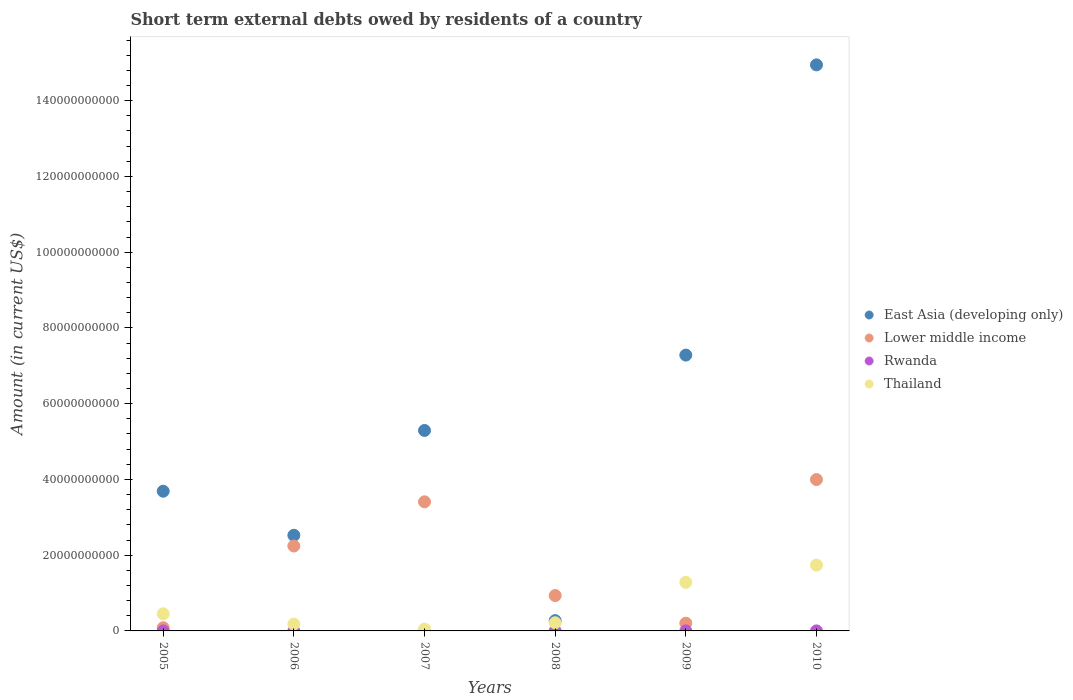Is the number of dotlines equal to the number of legend labels?
Keep it short and to the point. No. What is the amount of short-term external debts owed by residents in Rwanda in 2010?
Keep it short and to the point. 4.00e+06. Across all years, what is the maximum amount of short-term external debts owed by residents in Lower middle income?
Your response must be concise. 4.00e+1. Across all years, what is the minimum amount of short-term external debts owed by residents in East Asia (developing only)?
Offer a terse response. 2.72e+09. In which year was the amount of short-term external debts owed by residents in Lower middle income maximum?
Make the answer very short. 2010. What is the total amount of short-term external debts owed by residents in Lower middle income in the graph?
Provide a short and direct response. 1.09e+11. What is the difference between the amount of short-term external debts owed by residents in Rwanda in 2008 and that in 2010?
Keep it short and to the point. 9.99e+05. What is the difference between the amount of short-term external debts owed by residents in Lower middle income in 2005 and the amount of short-term external debts owed by residents in East Asia (developing only) in 2008?
Your response must be concise. -1.88e+09. What is the average amount of short-term external debts owed by residents in East Asia (developing only) per year?
Your answer should be very brief. 5.67e+1. In the year 2009, what is the difference between the amount of short-term external debts owed by residents in Lower middle income and amount of short-term external debts owed by residents in East Asia (developing only)?
Provide a short and direct response. -7.08e+1. In how many years, is the amount of short-term external debts owed by residents in East Asia (developing only) greater than 124000000000 US$?
Ensure brevity in your answer.  1. What is the ratio of the amount of short-term external debts owed by residents in East Asia (developing only) in 2007 to that in 2009?
Provide a short and direct response. 0.73. Is the amount of short-term external debts owed by residents in Lower middle income in 2005 less than that in 2007?
Your response must be concise. Yes. Is the difference between the amount of short-term external debts owed by residents in Lower middle income in 2006 and 2008 greater than the difference between the amount of short-term external debts owed by residents in East Asia (developing only) in 2006 and 2008?
Provide a short and direct response. No. What is the difference between the highest and the lowest amount of short-term external debts owed by residents in Thailand?
Provide a short and direct response. 1.69e+1. Is the sum of the amount of short-term external debts owed by residents in Lower middle income in 2009 and 2010 greater than the maximum amount of short-term external debts owed by residents in East Asia (developing only) across all years?
Offer a terse response. No. Is it the case that in every year, the sum of the amount of short-term external debts owed by residents in Rwanda and amount of short-term external debts owed by residents in East Asia (developing only)  is greater than the sum of amount of short-term external debts owed by residents in Thailand and amount of short-term external debts owed by residents in Lower middle income?
Your answer should be compact. No. Is the amount of short-term external debts owed by residents in Rwanda strictly less than the amount of short-term external debts owed by residents in East Asia (developing only) over the years?
Your answer should be very brief. Yes. How many years are there in the graph?
Keep it short and to the point. 6. Where does the legend appear in the graph?
Provide a succinct answer. Center right. How many legend labels are there?
Your answer should be very brief. 4. How are the legend labels stacked?
Your answer should be compact. Vertical. What is the title of the graph?
Ensure brevity in your answer.  Short term external debts owed by residents of a country. What is the label or title of the Y-axis?
Offer a very short reply. Amount (in current US$). What is the Amount (in current US$) in East Asia (developing only) in 2005?
Provide a succinct answer. 3.69e+1. What is the Amount (in current US$) of Lower middle income in 2005?
Offer a very short reply. 8.40e+08. What is the Amount (in current US$) of Thailand in 2005?
Make the answer very short. 4.53e+09. What is the Amount (in current US$) in East Asia (developing only) in 2006?
Make the answer very short. 2.53e+1. What is the Amount (in current US$) of Lower middle income in 2006?
Give a very brief answer. 2.24e+1. What is the Amount (in current US$) of Rwanda in 2006?
Give a very brief answer. 3.00e+06. What is the Amount (in current US$) in Thailand in 2006?
Your answer should be compact. 1.80e+09. What is the Amount (in current US$) of East Asia (developing only) in 2007?
Offer a terse response. 5.29e+1. What is the Amount (in current US$) of Lower middle income in 2007?
Your answer should be compact. 3.41e+1. What is the Amount (in current US$) of Rwanda in 2007?
Your answer should be very brief. 0. What is the Amount (in current US$) in Thailand in 2007?
Ensure brevity in your answer.  4.83e+08. What is the Amount (in current US$) in East Asia (developing only) in 2008?
Offer a terse response. 2.72e+09. What is the Amount (in current US$) in Lower middle income in 2008?
Provide a short and direct response. 9.34e+09. What is the Amount (in current US$) in Rwanda in 2008?
Provide a succinct answer. 5.00e+06. What is the Amount (in current US$) in Thailand in 2008?
Your response must be concise. 2.16e+09. What is the Amount (in current US$) of East Asia (developing only) in 2009?
Offer a terse response. 7.28e+1. What is the Amount (in current US$) in Lower middle income in 2009?
Provide a succinct answer. 2.04e+09. What is the Amount (in current US$) in Rwanda in 2009?
Your answer should be very brief. 5.00e+06. What is the Amount (in current US$) of Thailand in 2009?
Offer a terse response. 1.28e+1. What is the Amount (in current US$) in East Asia (developing only) in 2010?
Keep it short and to the point. 1.49e+11. What is the Amount (in current US$) in Lower middle income in 2010?
Offer a terse response. 4.00e+1. What is the Amount (in current US$) in Rwanda in 2010?
Your answer should be very brief. 4.00e+06. What is the Amount (in current US$) in Thailand in 2010?
Your answer should be compact. 1.74e+1. Across all years, what is the maximum Amount (in current US$) in East Asia (developing only)?
Your answer should be compact. 1.49e+11. Across all years, what is the maximum Amount (in current US$) of Lower middle income?
Offer a terse response. 4.00e+1. Across all years, what is the maximum Amount (in current US$) of Thailand?
Give a very brief answer. 1.74e+1. Across all years, what is the minimum Amount (in current US$) in East Asia (developing only)?
Your answer should be compact. 2.72e+09. Across all years, what is the minimum Amount (in current US$) of Lower middle income?
Make the answer very short. 8.40e+08. Across all years, what is the minimum Amount (in current US$) in Rwanda?
Your answer should be very brief. 0. Across all years, what is the minimum Amount (in current US$) of Thailand?
Make the answer very short. 4.83e+08. What is the total Amount (in current US$) of East Asia (developing only) in the graph?
Offer a terse response. 3.40e+11. What is the total Amount (in current US$) of Lower middle income in the graph?
Provide a succinct answer. 1.09e+11. What is the total Amount (in current US$) of Rwanda in the graph?
Offer a terse response. 1.70e+07. What is the total Amount (in current US$) of Thailand in the graph?
Give a very brief answer. 3.92e+1. What is the difference between the Amount (in current US$) in East Asia (developing only) in 2005 and that in 2006?
Your response must be concise. 1.16e+1. What is the difference between the Amount (in current US$) of Lower middle income in 2005 and that in 2006?
Offer a terse response. -2.16e+1. What is the difference between the Amount (in current US$) in Thailand in 2005 and that in 2006?
Offer a very short reply. 2.73e+09. What is the difference between the Amount (in current US$) of East Asia (developing only) in 2005 and that in 2007?
Your answer should be compact. -1.60e+1. What is the difference between the Amount (in current US$) in Lower middle income in 2005 and that in 2007?
Offer a very short reply. -3.32e+1. What is the difference between the Amount (in current US$) in Thailand in 2005 and that in 2007?
Your answer should be very brief. 4.04e+09. What is the difference between the Amount (in current US$) in East Asia (developing only) in 2005 and that in 2008?
Give a very brief answer. 3.42e+1. What is the difference between the Amount (in current US$) in Lower middle income in 2005 and that in 2008?
Offer a very short reply. -8.50e+09. What is the difference between the Amount (in current US$) of Thailand in 2005 and that in 2008?
Make the answer very short. 2.37e+09. What is the difference between the Amount (in current US$) of East Asia (developing only) in 2005 and that in 2009?
Offer a terse response. -3.59e+1. What is the difference between the Amount (in current US$) of Lower middle income in 2005 and that in 2009?
Provide a short and direct response. -1.20e+09. What is the difference between the Amount (in current US$) in Thailand in 2005 and that in 2009?
Keep it short and to the point. -8.30e+09. What is the difference between the Amount (in current US$) of East Asia (developing only) in 2005 and that in 2010?
Give a very brief answer. -1.13e+11. What is the difference between the Amount (in current US$) in Lower middle income in 2005 and that in 2010?
Keep it short and to the point. -3.91e+1. What is the difference between the Amount (in current US$) in Thailand in 2005 and that in 2010?
Make the answer very short. -1.29e+1. What is the difference between the Amount (in current US$) in East Asia (developing only) in 2006 and that in 2007?
Offer a very short reply. -2.77e+1. What is the difference between the Amount (in current US$) of Lower middle income in 2006 and that in 2007?
Give a very brief answer. -1.17e+1. What is the difference between the Amount (in current US$) in Thailand in 2006 and that in 2007?
Keep it short and to the point. 1.32e+09. What is the difference between the Amount (in current US$) in East Asia (developing only) in 2006 and that in 2008?
Your answer should be compact. 2.25e+1. What is the difference between the Amount (in current US$) of Lower middle income in 2006 and that in 2008?
Offer a very short reply. 1.31e+1. What is the difference between the Amount (in current US$) in Rwanda in 2006 and that in 2008?
Offer a very short reply. -2.00e+06. What is the difference between the Amount (in current US$) in Thailand in 2006 and that in 2008?
Give a very brief answer. -3.58e+08. What is the difference between the Amount (in current US$) of East Asia (developing only) in 2006 and that in 2009?
Keep it short and to the point. -4.76e+1. What is the difference between the Amount (in current US$) of Lower middle income in 2006 and that in 2009?
Provide a succinct answer. 2.04e+1. What is the difference between the Amount (in current US$) of Thailand in 2006 and that in 2009?
Ensure brevity in your answer.  -1.10e+1. What is the difference between the Amount (in current US$) of East Asia (developing only) in 2006 and that in 2010?
Your answer should be compact. -1.24e+11. What is the difference between the Amount (in current US$) in Lower middle income in 2006 and that in 2010?
Offer a terse response. -1.75e+1. What is the difference between the Amount (in current US$) in Rwanda in 2006 and that in 2010?
Provide a short and direct response. -1.00e+06. What is the difference between the Amount (in current US$) of Thailand in 2006 and that in 2010?
Provide a short and direct response. -1.56e+1. What is the difference between the Amount (in current US$) in East Asia (developing only) in 2007 and that in 2008?
Your answer should be compact. 5.02e+1. What is the difference between the Amount (in current US$) of Lower middle income in 2007 and that in 2008?
Give a very brief answer. 2.47e+1. What is the difference between the Amount (in current US$) in Thailand in 2007 and that in 2008?
Provide a succinct answer. -1.67e+09. What is the difference between the Amount (in current US$) in East Asia (developing only) in 2007 and that in 2009?
Give a very brief answer. -1.99e+1. What is the difference between the Amount (in current US$) in Lower middle income in 2007 and that in 2009?
Offer a terse response. 3.20e+1. What is the difference between the Amount (in current US$) in Thailand in 2007 and that in 2009?
Your answer should be very brief. -1.23e+1. What is the difference between the Amount (in current US$) of East Asia (developing only) in 2007 and that in 2010?
Offer a very short reply. -9.65e+1. What is the difference between the Amount (in current US$) in Lower middle income in 2007 and that in 2010?
Provide a succinct answer. -5.88e+09. What is the difference between the Amount (in current US$) in Thailand in 2007 and that in 2010?
Your response must be concise. -1.69e+1. What is the difference between the Amount (in current US$) of East Asia (developing only) in 2008 and that in 2009?
Your answer should be compact. -7.01e+1. What is the difference between the Amount (in current US$) in Lower middle income in 2008 and that in 2009?
Give a very brief answer. 7.30e+09. What is the difference between the Amount (in current US$) of Rwanda in 2008 and that in 2009?
Offer a very short reply. -1000. What is the difference between the Amount (in current US$) of Thailand in 2008 and that in 2009?
Offer a terse response. -1.07e+1. What is the difference between the Amount (in current US$) in East Asia (developing only) in 2008 and that in 2010?
Offer a very short reply. -1.47e+11. What is the difference between the Amount (in current US$) in Lower middle income in 2008 and that in 2010?
Keep it short and to the point. -3.06e+1. What is the difference between the Amount (in current US$) of Rwanda in 2008 and that in 2010?
Provide a short and direct response. 9.99e+05. What is the difference between the Amount (in current US$) of Thailand in 2008 and that in 2010?
Provide a short and direct response. -1.52e+1. What is the difference between the Amount (in current US$) in East Asia (developing only) in 2009 and that in 2010?
Your response must be concise. -7.66e+1. What is the difference between the Amount (in current US$) of Lower middle income in 2009 and that in 2010?
Offer a very short reply. -3.79e+1. What is the difference between the Amount (in current US$) of Rwanda in 2009 and that in 2010?
Make the answer very short. 1.00e+06. What is the difference between the Amount (in current US$) of Thailand in 2009 and that in 2010?
Offer a very short reply. -4.55e+09. What is the difference between the Amount (in current US$) in East Asia (developing only) in 2005 and the Amount (in current US$) in Lower middle income in 2006?
Keep it short and to the point. 1.45e+1. What is the difference between the Amount (in current US$) in East Asia (developing only) in 2005 and the Amount (in current US$) in Rwanda in 2006?
Your answer should be very brief. 3.69e+1. What is the difference between the Amount (in current US$) in East Asia (developing only) in 2005 and the Amount (in current US$) in Thailand in 2006?
Your response must be concise. 3.51e+1. What is the difference between the Amount (in current US$) in Lower middle income in 2005 and the Amount (in current US$) in Rwanda in 2006?
Offer a very short reply. 8.37e+08. What is the difference between the Amount (in current US$) of Lower middle income in 2005 and the Amount (in current US$) of Thailand in 2006?
Your response must be concise. -9.58e+08. What is the difference between the Amount (in current US$) of East Asia (developing only) in 2005 and the Amount (in current US$) of Lower middle income in 2007?
Give a very brief answer. 2.80e+09. What is the difference between the Amount (in current US$) of East Asia (developing only) in 2005 and the Amount (in current US$) of Thailand in 2007?
Keep it short and to the point. 3.64e+1. What is the difference between the Amount (in current US$) of Lower middle income in 2005 and the Amount (in current US$) of Thailand in 2007?
Make the answer very short. 3.57e+08. What is the difference between the Amount (in current US$) of East Asia (developing only) in 2005 and the Amount (in current US$) of Lower middle income in 2008?
Offer a very short reply. 2.75e+1. What is the difference between the Amount (in current US$) in East Asia (developing only) in 2005 and the Amount (in current US$) in Rwanda in 2008?
Give a very brief answer. 3.69e+1. What is the difference between the Amount (in current US$) of East Asia (developing only) in 2005 and the Amount (in current US$) of Thailand in 2008?
Your response must be concise. 3.47e+1. What is the difference between the Amount (in current US$) of Lower middle income in 2005 and the Amount (in current US$) of Rwanda in 2008?
Your answer should be compact. 8.35e+08. What is the difference between the Amount (in current US$) in Lower middle income in 2005 and the Amount (in current US$) in Thailand in 2008?
Make the answer very short. -1.32e+09. What is the difference between the Amount (in current US$) of East Asia (developing only) in 2005 and the Amount (in current US$) of Lower middle income in 2009?
Provide a short and direct response. 3.48e+1. What is the difference between the Amount (in current US$) in East Asia (developing only) in 2005 and the Amount (in current US$) in Rwanda in 2009?
Your response must be concise. 3.69e+1. What is the difference between the Amount (in current US$) of East Asia (developing only) in 2005 and the Amount (in current US$) of Thailand in 2009?
Give a very brief answer. 2.41e+1. What is the difference between the Amount (in current US$) in Lower middle income in 2005 and the Amount (in current US$) in Rwanda in 2009?
Your answer should be very brief. 8.35e+08. What is the difference between the Amount (in current US$) of Lower middle income in 2005 and the Amount (in current US$) of Thailand in 2009?
Ensure brevity in your answer.  -1.20e+1. What is the difference between the Amount (in current US$) in East Asia (developing only) in 2005 and the Amount (in current US$) in Lower middle income in 2010?
Ensure brevity in your answer.  -3.08e+09. What is the difference between the Amount (in current US$) in East Asia (developing only) in 2005 and the Amount (in current US$) in Rwanda in 2010?
Offer a terse response. 3.69e+1. What is the difference between the Amount (in current US$) of East Asia (developing only) in 2005 and the Amount (in current US$) of Thailand in 2010?
Offer a terse response. 1.95e+1. What is the difference between the Amount (in current US$) of Lower middle income in 2005 and the Amount (in current US$) of Rwanda in 2010?
Your answer should be very brief. 8.36e+08. What is the difference between the Amount (in current US$) of Lower middle income in 2005 and the Amount (in current US$) of Thailand in 2010?
Your answer should be compact. -1.65e+1. What is the difference between the Amount (in current US$) of East Asia (developing only) in 2006 and the Amount (in current US$) of Lower middle income in 2007?
Your answer should be very brief. -8.83e+09. What is the difference between the Amount (in current US$) of East Asia (developing only) in 2006 and the Amount (in current US$) of Thailand in 2007?
Provide a short and direct response. 2.48e+1. What is the difference between the Amount (in current US$) of Lower middle income in 2006 and the Amount (in current US$) of Thailand in 2007?
Provide a short and direct response. 2.19e+1. What is the difference between the Amount (in current US$) of Rwanda in 2006 and the Amount (in current US$) of Thailand in 2007?
Keep it short and to the point. -4.80e+08. What is the difference between the Amount (in current US$) in East Asia (developing only) in 2006 and the Amount (in current US$) in Lower middle income in 2008?
Provide a succinct answer. 1.59e+1. What is the difference between the Amount (in current US$) in East Asia (developing only) in 2006 and the Amount (in current US$) in Rwanda in 2008?
Make the answer very short. 2.52e+1. What is the difference between the Amount (in current US$) in East Asia (developing only) in 2006 and the Amount (in current US$) in Thailand in 2008?
Ensure brevity in your answer.  2.31e+1. What is the difference between the Amount (in current US$) of Lower middle income in 2006 and the Amount (in current US$) of Rwanda in 2008?
Your answer should be very brief. 2.24e+1. What is the difference between the Amount (in current US$) of Lower middle income in 2006 and the Amount (in current US$) of Thailand in 2008?
Provide a short and direct response. 2.03e+1. What is the difference between the Amount (in current US$) of Rwanda in 2006 and the Amount (in current US$) of Thailand in 2008?
Keep it short and to the point. -2.15e+09. What is the difference between the Amount (in current US$) of East Asia (developing only) in 2006 and the Amount (in current US$) of Lower middle income in 2009?
Ensure brevity in your answer.  2.32e+1. What is the difference between the Amount (in current US$) in East Asia (developing only) in 2006 and the Amount (in current US$) in Rwanda in 2009?
Provide a short and direct response. 2.52e+1. What is the difference between the Amount (in current US$) in East Asia (developing only) in 2006 and the Amount (in current US$) in Thailand in 2009?
Ensure brevity in your answer.  1.24e+1. What is the difference between the Amount (in current US$) of Lower middle income in 2006 and the Amount (in current US$) of Rwanda in 2009?
Keep it short and to the point. 2.24e+1. What is the difference between the Amount (in current US$) of Lower middle income in 2006 and the Amount (in current US$) of Thailand in 2009?
Give a very brief answer. 9.60e+09. What is the difference between the Amount (in current US$) of Rwanda in 2006 and the Amount (in current US$) of Thailand in 2009?
Ensure brevity in your answer.  -1.28e+1. What is the difference between the Amount (in current US$) in East Asia (developing only) in 2006 and the Amount (in current US$) in Lower middle income in 2010?
Your response must be concise. -1.47e+1. What is the difference between the Amount (in current US$) in East Asia (developing only) in 2006 and the Amount (in current US$) in Rwanda in 2010?
Provide a short and direct response. 2.52e+1. What is the difference between the Amount (in current US$) in East Asia (developing only) in 2006 and the Amount (in current US$) in Thailand in 2010?
Your answer should be compact. 7.87e+09. What is the difference between the Amount (in current US$) of Lower middle income in 2006 and the Amount (in current US$) of Rwanda in 2010?
Offer a terse response. 2.24e+1. What is the difference between the Amount (in current US$) in Lower middle income in 2006 and the Amount (in current US$) in Thailand in 2010?
Your answer should be very brief. 5.05e+09. What is the difference between the Amount (in current US$) of Rwanda in 2006 and the Amount (in current US$) of Thailand in 2010?
Your answer should be very brief. -1.74e+1. What is the difference between the Amount (in current US$) in East Asia (developing only) in 2007 and the Amount (in current US$) in Lower middle income in 2008?
Offer a very short reply. 4.36e+1. What is the difference between the Amount (in current US$) in East Asia (developing only) in 2007 and the Amount (in current US$) in Rwanda in 2008?
Make the answer very short. 5.29e+1. What is the difference between the Amount (in current US$) in East Asia (developing only) in 2007 and the Amount (in current US$) in Thailand in 2008?
Your answer should be very brief. 5.08e+1. What is the difference between the Amount (in current US$) of Lower middle income in 2007 and the Amount (in current US$) of Rwanda in 2008?
Your answer should be compact. 3.41e+1. What is the difference between the Amount (in current US$) in Lower middle income in 2007 and the Amount (in current US$) in Thailand in 2008?
Make the answer very short. 3.19e+1. What is the difference between the Amount (in current US$) in East Asia (developing only) in 2007 and the Amount (in current US$) in Lower middle income in 2009?
Your answer should be compact. 5.09e+1. What is the difference between the Amount (in current US$) in East Asia (developing only) in 2007 and the Amount (in current US$) in Rwanda in 2009?
Give a very brief answer. 5.29e+1. What is the difference between the Amount (in current US$) of East Asia (developing only) in 2007 and the Amount (in current US$) of Thailand in 2009?
Provide a succinct answer. 4.01e+1. What is the difference between the Amount (in current US$) of Lower middle income in 2007 and the Amount (in current US$) of Rwanda in 2009?
Ensure brevity in your answer.  3.41e+1. What is the difference between the Amount (in current US$) in Lower middle income in 2007 and the Amount (in current US$) in Thailand in 2009?
Your response must be concise. 2.13e+1. What is the difference between the Amount (in current US$) of East Asia (developing only) in 2007 and the Amount (in current US$) of Lower middle income in 2010?
Give a very brief answer. 1.30e+1. What is the difference between the Amount (in current US$) of East Asia (developing only) in 2007 and the Amount (in current US$) of Rwanda in 2010?
Give a very brief answer. 5.29e+1. What is the difference between the Amount (in current US$) in East Asia (developing only) in 2007 and the Amount (in current US$) in Thailand in 2010?
Provide a succinct answer. 3.56e+1. What is the difference between the Amount (in current US$) in Lower middle income in 2007 and the Amount (in current US$) in Rwanda in 2010?
Provide a succinct answer. 3.41e+1. What is the difference between the Amount (in current US$) in Lower middle income in 2007 and the Amount (in current US$) in Thailand in 2010?
Offer a very short reply. 1.67e+1. What is the difference between the Amount (in current US$) in East Asia (developing only) in 2008 and the Amount (in current US$) in Lower middle income in 2009?
Keep it short and to the point. 6.74e+08. What is the difference between the Amount (in current US$) in East Asia (developing only) in 2008 and the Amount (in current US$) in Rwanda in 2009?
Make the answer very short. 2.71e+09. What is the difference between the Amount (in current US$) of East Asia (developing only) in 2008 and the Amount (in current US$) of Thailand in 2009?
Provide a short and direct response. -1.01e+1. What is the difference between the Amount (in current US$) of Lower middle income in 2008 and the Amount (in current US$) of Rwanda in 2009?
Provide a short and direct response. 9.33e+09. What is the difference between the Amount (in current US$) of Lower middle income in 2008 and the Amount (in current US$) of Thailand in 2009?
Offer a very short reply. -3.49e+09. What is the difference between the Amount (in current US$) of Rwanda in 2008 and the Amount (in current US$) of Thailand in 2009?
Your response must be concise. -1.28e+1. What is the difference between the Amount (in current US$) of East Asia (developing only) in 2008 and the Amount (in current US$) of Lower middle income in 2010?
Your response must be concise. -3.73e+1. What is the difference between the Amount (in current US$) of East Asia (developing only) in 2008 and the Amount (in current US$) of Rwanda in 2010?
Provide a succinct answer. 2.71e+09. What is the difference between the Amount (in current US$) of East Asia (developing only) in 2008 and the Amount (in current US$) of Thailand in 2010?
Ensure brevity in your answer.  -1.47e+1. What is the difference between the Amount (in current US$) in Lower middle income in 2008 and the Amount (in current US$) in Rwanda in 2010?
Provide a succinct answer. 9.34e+09. What is the difference between the Amount (in current US$) in Lower middle income in 2008 and the Amount (in current US$) in Thailand in 2010?
Your response must be concise. -8.04e+09. What is the difference between the Amount (in current US$) of Rwanda in 2008 and the Amount (in current US$) of Thailand in 2010?
Provide a succinct answer. -1.74e+1. What is the difference between the Amount (in current US$) of East Asia (developing only) in 2009 and the Amount (in current US$) of Lower middle income in 2010?
Your answer should be very brief. 3.29e+1. What is the difference between the Amount (in current US$) of East Asia (developing only) in 2009 and the Amount (in current US$) of Rwanda in 2010?
Offer a very short reply. 7.28e+1. What is the difference between the Amount (in current US$) of East Asia (developing only) in 2009 and the Amount (in current US$) of Thailand in 2010?
Your answer should be very brief. 5.54e+1. What is the difference between the Amount (in current US$) in Lower middle income in 2009 and the Amount (in current US$) in Rwanda in 2010?
Offer a terse response. 2.04e+09. What is the difference between the Amount (in current US$) in Lower middle income in 2009 and the Amount (in current US$) in Thailand in 2010?
Your answer should be very brief. -1.53e+1. What is the difference between the Amount (in current US$) of Rwanda in 2009 and the Amount (in current US$) of Thailand in 2010?
Keep it short and to the point. -1.74e+1. What is the average Amount (in current US$) of East Asia (developing only) per year?
Your response must be concise. 5.67e+1. What is the average Amount (in current US$) of Lower middle income per year?
Provide a succinct answer. 1.81e+1. What is the average Amount (in current US$) of Rwanda per year?
Keep it short and to the point. 2.83e+06. What is the average Amount (in current US$) in Thailand per year?
Provide a succinct answer. 6.53e+09. In the year 2005, what is the difference between the Amount (in current US$) of East Asia (developing only) and Amount (in current US$) of Lower middle income?
Provide a succinct answer. 3.60e+1. In the year 2005, what is the difference between the Amount (in current US$) of East Asia (developing only) and Amount (in current US$) of Thailand?
Make the answer very short. 3.24e+1. In the year 2005, what is the difference between the Amount (in current US$) in Lower middle income and Amount (in current US$) in Thailand?
Offer a very short reply. -3.69e+09. In the year 2006, what is the difference between the Amount (in current US$) in East Asia (developing only) and Amount (in current US$) in Lower middle income?
Ensure brevity in your answer.  2.83e+09. In the year 2006, what is the difference between the Amount (in current US$) in East Asia (developing only) and Amount (in current US$) in Rwanda?
Provide a succinct answer. 2.52e+1. In the year 2006, what is the difference between the Amount (in current US$) of East Asia (developing only) and Amount (in current US$) of Thailand?
Offer a terse response. 2.35e+1. In the year 2006, what is the difference between the Amount (in current US$) in Lower middle income and Amount (in current US$) in Rwanda?
Your answer should be compact. 2.24e+1. In the year 2006, what is the difference between the Amount (in current US$) of Lower middle income and Amount (in current US$) of Thailand?
Your response must be concise. 2.06e+1. In the year 2006, what is the difference between the Amount (in current US$) of Rwanda and Amount (in current US$) of Thailand?
Your answer should be compact. -1.80e+09. In the year 2007, what is the difference between the Amount (in current US$) of East Asia (developing only) and Amount (in current US$) of Lower middle income?
Offer a very short reply. 1.88e+1. In the year 2007, what is the difference between the Amount (in current US$) of East Asia (developing only) and Amount (in current US$) of Thailand?
Offer a very short reply. 5.24e+1. In the year 2007, what is the difference between the Amount (in current US$) in Lower middle income and Amount (in current US$) in Thailand?
Make the answer very short. 3.36e+1. In the year 2008, what is the difference between the Amount (in current US$) of East Asia (developing only) and Amount (in current US$) of Lower middle income?
Provide a succinct answer. -6.62e+09. In the year 2008, what is the difference between the Amount (in current US$) of East Asia (developing only) and Amount (in current US$) of Rwanda?
Your answer should be compact. 2.71e+09. In the year 2008, what is the difference between the Amount (in current US$) of East Asia (developing only) and Amount (in current US$) of Thailand?
Your response must be concise. 5.59e+08. In the year 2008, what is the difference between the Amount (in current US$) of Lower middle income and Amount (in current US$) of Rwanda?
Keep it short and to the point. 9.33e+09. In the year 2008, what is the difference between the Amount (in current US$) of Lower middle income and Amount (in current US$) of Thailand?
Provide a succinct answer. 7.18e+09. In the year 2008, what is the difference between the Amount (in current US$) of Rwanda and Amount (in current US$) of Thailand?
Your answer should be compact. -2.15e+09. In the year 2009, what is the difference between the Amount (in current US$) in East Asia (developing only) and Amount (in current US$) in Lower middle income?
Your response must be concise. 7.08e+1. In the year 2009, what is the difference between the Amount (in current US$) in East Asia (developing only) and Amount (in current US$) in Rwanda?
Make the answer very short. 7.28e+1. In the year 2009, what is the difference between the Amount (in current US$) in East Asia (developing only) and Amount (in current US$) in Thailand?
Offer a terse response. 6.00e+1. In the year 2009, what is the difference between the Amount (in current US$) of Lower middle income and Amount (in current US$) of Rwanda?
Make the answer very short. 2.04e+09. In the year 2009, what is the difference between the Amount (in current US$) in Lower middle income and Amount (in current US$) in Thailand?
Provide a succinct answer. -1.08e+1. In the year 2009, what is the difference between the Amount (in current US$) in Rwanda and Amount (in current US$) in Thailand?
Make the answer very short. -1.28e+1. In the year 2010, what is the difference between the Amount (in current US$) in East Asia (developing only) and Amount (in current US$) in Lower middle income?
Your answer should be compact. 1.09e+11. In the year 2010, what is the difference between the Amount (in current US$) of East Asia (developing only) and Amount (in current US$) of Rwanda?
Ensure brevity in your answer.  1.49e+11. In the year 2010, what is the difference between the Amount (in current US$) of East Asia (developing only) and Amount (in current US$) of Thailand?
Offer a very short reply. 1.32e+11. In the year 2010, what is the difference between the Amount (in current US$) of Lower middle income and Amount (in current US$) of Rwanda?
Offer a terse response. 4.00e+1. In the year 2010, what is the difference between the Amount (in current US$) of Lower middle income and Amount (in current US$) of Thailand?
Your response must be concise. 2.26e+1. In the year 2010, what is the difference between the Amount (in current US$) of Rwanda and Amount (in current US$) of Thailand?
Offer a very short reply. -1.74e+1. What is the ratio of the Amount (in current US$) in East Asia (developing only) in 2005 to that in 2006?
Ensure brevity in your answer.  1.46. What is the ratio of the Amount (in current US$) of Lower middle income in 2005 to that in 2006?
Ensure brevity in your answer.  0.04. What is the ratio of the Amount (in current US$) of Thailand in 2005 to that in 2006?
Offer a terse response. 2.52. What is the ratio of the Amount (in current US$) of East Asia (developing only) in 2005 to that in 2007?
Give a very brief answer. 0.7. What is the ratio of the Amount (in current US$) of Lower middle income in 2005 to that in 2007?
Offer a terse response. 0.02. What is the ratio of the Amount (in current US$) of Thailand in 2005 to that in 2007?
Make the answer very short. 9.37. What is the ratio of the Amount (in current US$) in East Asia (developing only) in 2005 to that in 2008?
Your response must be concise. 13.59. What is the ratio of the Amount (in current US$) of Lower middle income in 2005 to that in 2008?
Give a very brief answer. 0.09. What is the ratio of the Amount (in current US$) of Thailand in 2005 to that in 2008?
Offer a very short reply. 2.1. What is the ratio of the Amount (in current US$) of East Asia (developing only) in 2005 to that in 2009?
Your answer should be compact. 0.51. What is the ratio of the Amount (in current US$) in Lower middle income in 2005 to that in 2009?
Your answer should be compact. 0.41. What is the ratio of the Amount (in current US$) of Thailand in 2005 to that in 2009?
Offer a very short reply. 0.35. What is the ratio of the Amount (in current US$) in East Asia (developing only) in 2005 to that in 2010?
Ensure brevity in your answer.  0.25. What is the ratio of the Amount (in current US$) of Lower middle income in 2005 to that in 2010?
Provide a short and direct response. 0.02. What is the ratio of the Amount (in current US$) of Thailand in 2005 to that in 2010?
Your answer should be very brief. 0.26. What is the ratio of the Amount (in current US$) in East Asia (developing only) in 2006 to that in 2007?
Give a very brief answer. 0.48. What is the ratio of the Amount (in current US$) in Lower middle income in 2006 to that in 2007?
Keep it short and to the point. 0.66. What is the ratio of the Amount (in current US$) in Thailand in 2006 to that in 2007?
Your answer should be compact. 3.72. What is the ratio of the Amount (in current US$) in East Asia (developing only) in 2006 to that in 2008?
Your answer should be very brief. 9.3. What is the ratio of the Amount (in current US$) in Lower middle income in 2006 to that in 2008?
Ensure brevity in your answer.  2.4. What is the ratio of the Amount (in current US$) of Rwanda in 2006 to that in 2008?
Make the answer very short. 0.6. What is the ratio of the Amount (in current US$) of Thailand in 2006 to that in 2008?
Your answer should be compact. 0.83. What is the ratio of the Amount (in current US$) in East Asia (developing only) in 2006 to that in 2009?
Give a very brief answer. 0.35. What is the ratio of the Amount (in current US$) of Lower middle income in 2006 to that in 2009?
Make the answer very short. 10.99. What is the ratio of the Amount (in current US$) in Thailand in 2006 to that in 2009?
Make the answer very short. 0.14. What is the ratio of the Amount (in current US$) of East Asia (developing only) in 2006 to that in 2010?
Give a very brief answer. 0.17. What is the ratio of the Amount (in current US$) in Lower middle income in 2006 to that in 2010?
Offer a very short reply. 0.56. What is the ratio of the Amount (in current US$) of Rwanda in 2006 to that in 2010?
Ensure brevity in your answer.  0.75. What is the ratio of the Amount (in current US$) in Thailand in 2006 to that in 2010?
Offer a very short reply. 0.1. What is the ratio of the Amount (in current US$) of East Asia (developing only) in 2007 to that in 2008?
Your answer should be very brief. 19.49. What is the ratio of the Amount (in current US$) of Lower middle income in 2007 to that in 2008?
Make the answer very short. 3.65. What is the ratio of the Amount (in current US$) of Thailand in 2007 to that in 2008?
Offer a terse response. 0.22. What is the ratio of the Amount (in current US$) of East Asia (developing only) in 2007 to that in 2009?
Ensure brevity in your answer.  0.73. What is the ratio of the Amount (in current US$) of Lower middle income in 2007 to that in 2009?
Provide a succinct answer. 16.7. What is the ratio of the Amount (in current US$) of Thailand in 2007 to that in 2009?
Ensure brevity in your answer.  0.04. What is the ratio of the Amount (in current US$) of East Asia (developing only) in 2007 to that in 2010?
Give a very brief answer. 0.35. What is the ratio of the Amount (in current US$) in Lower middle income in 2007 to that in 2010?
Offer a terse response. 0.85. What is the ratio of the Amount (in current US$) of Thailand in 2007 to that in 2010?
Your answer should be very brief. 0.03. What is the ratio of the Amount (in current US$) of East Asia (developing only) in 2008 to that in 2009?
Your response must be concise. 0.04. What is the ratio of the Amount (in current US$) in Lower middle income in 2008 to that in 2009?
Give a very brief answer. 4.58. What is the ratio of the Amount (in current US$) in Thailand in 2008 to that in 2009?
Make the answer very short. 0.17. What is the ratio of the Amount (in current US$) of East Asia (developing only) in 2008 to that in 2010?
Your response must be concise. 0.02. What is the ratio of the Amount (in current US$) in Lower middle income in 2008 to that in 2010?
Your answer should be compact. 0.23. What is the ratio of the Amount (in current US$) in Rwanda in 2008 to that in 2010?
Your answer should be compact. 1.25. What is the ratio of the Amount (in current US$) in Thailand in 2008 to that in 2010?
Ensure brevity in your answer.  0.12. What is the ratio of the Amount (in current US$) of East Asia (developing only) in 2009 to that in 2010?
Your answer should be compact. 0.49. What is the ratio of the Amount (in current US$) in Lower middle income in 2009 to that in 2010?
Your answer should be very brief. 0.05. What is the ratio of the Amount (in current US$) of Thailand in 2009 to that in 2010?
Provide a short and direct response. 0.74. What is the difference between the highest and the second highest Amount (in current US$) in East Asia (developing only)?
Make the answer very short. 7.66e+1. What is the difference between the highest and the second highest Amount (in current US$) of Lower middle income?
Provide a short and direct response. 5.88e+09. What is the difference between the highest and the second highest Amount (in current US$) in Thailand?
Your answer should be very brief. 4.55e+09. What is the difference between the highest and the lowest Amount (in current US$) of East Asia (developing only)?
Keep it short and to the point. 1.47e+11. What is the difference between the highest and the lowest Amount (in current US$) of Lower middle income?
Keep it short and to the point. 3.91e+1. What is the difference between the highest and the lowest Amount (in current US$) in Rwanda?
Ensure brevity in your answer.  5.00e+06. What is the difference between the highest and the lowest Amount (in current US$) in Thailand?
Your answer should be very brief. 1.69e+1. 